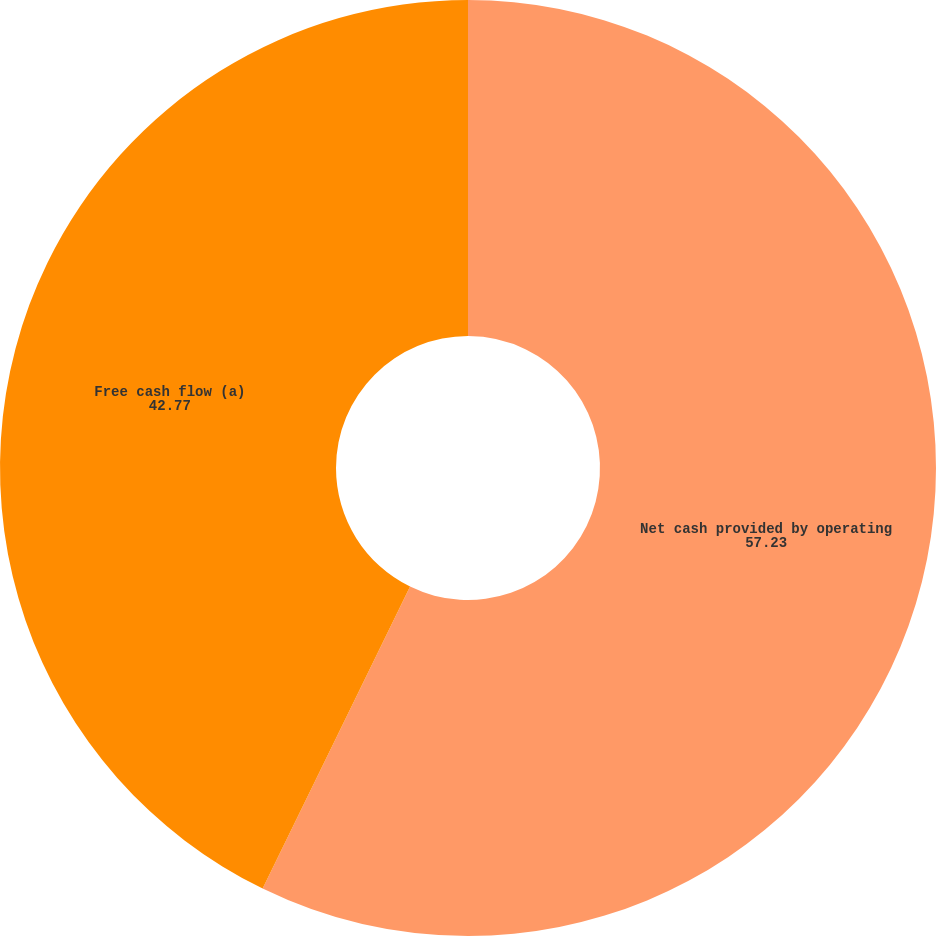Convert chart. <chart><loc_0><loc_0><loc_500><loc_500><pie_chart><fcel>Net cash provided by operating<fcel>Free cash flow (a)<nl><fcel>57.23%<fcel>42.77%<nl></chart> 